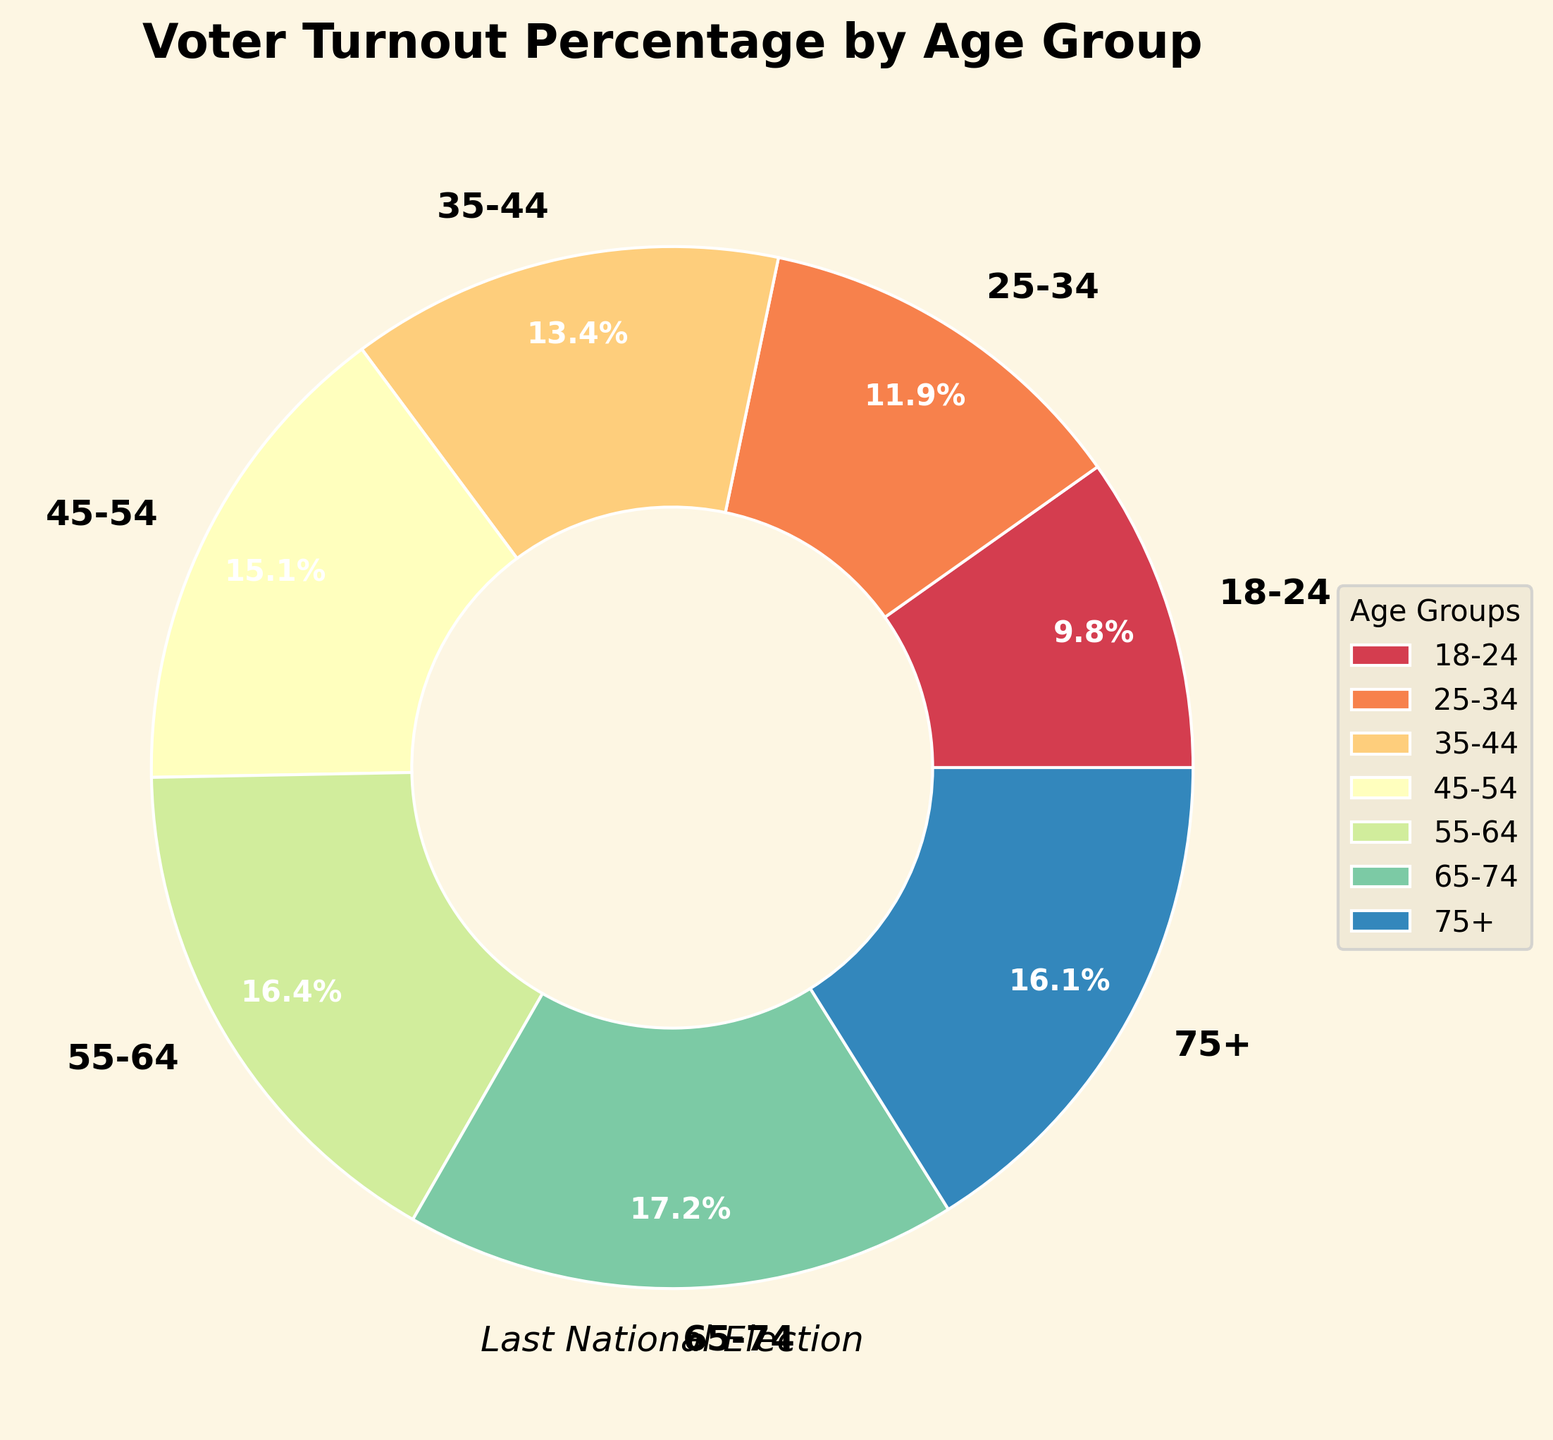Which age group had the highest voter turnout percentage? The pie chart shows that the age group 65-74 has the highest voter turnout percentage at 74.6%.
Answer: 65-74 Which age group had the lowest turnout and what was their percentage? The pie chart indicates that the age group 18-24 had the lowest voter turnout percentage at 42.5%.
Answer: 18-24, 42.5% How does the voter turnout percentage of the 45-54 age group compare to that of the 55-64 age group? To compare, we look at the percentages: 45-54 has 65.7% turnout, while 55-64 has 71.2%. The 55-64 age group has a higher turnout.
Answer: 55-64 age group has a higher turnout Sum the voter turnout percentages for the age groups 18-24, 25-34, and 35-44. The percentages for the 18-24, 25-34, and 35-44 age groups are 42.5%, 51.8%, and 58.3% respectively. Adding them gives 42.5 + 51.8 + 58.3 = 152.6%.
Answer: 152.6% What is the difference in voter turnout percentage between the youngest and oldest age groups? The youngest age group (18-24) has a turnout of 42.5% and the oldest age group (75+) has a turnout of 69.9%. The difference is 69.9 - 42.5 = 27.4%.
Answer: 27.4% What is the average voter turnout percentage across all age groups? To calculate the average, sum up all the voter turnout percentages and divide by the number of age groups. (42.5 + 51.8 + 58.3 + 65.7 + 71.2 + 74.6 + 69.9) / 7 = 61.429%.
Answer: 61.4% Which two age groups have the closest voter turnout percentages and what is their difference? By examining the turnout percentages, the closest two are 55-64 (71.2%) and 65-74 (74.6%). The difference is 74.6 - 71.2 = 3.4%.
Answer: 55-64 and 65-74, 3.4% Does any age group's voter turnout surpass 70%? If so, which ones? Looking at the pie chart, the age groups 55-64 (71.2%) and 65-74 (74.6%) surpass 70% voter turnout.
Answer: 55-64, 65-74 